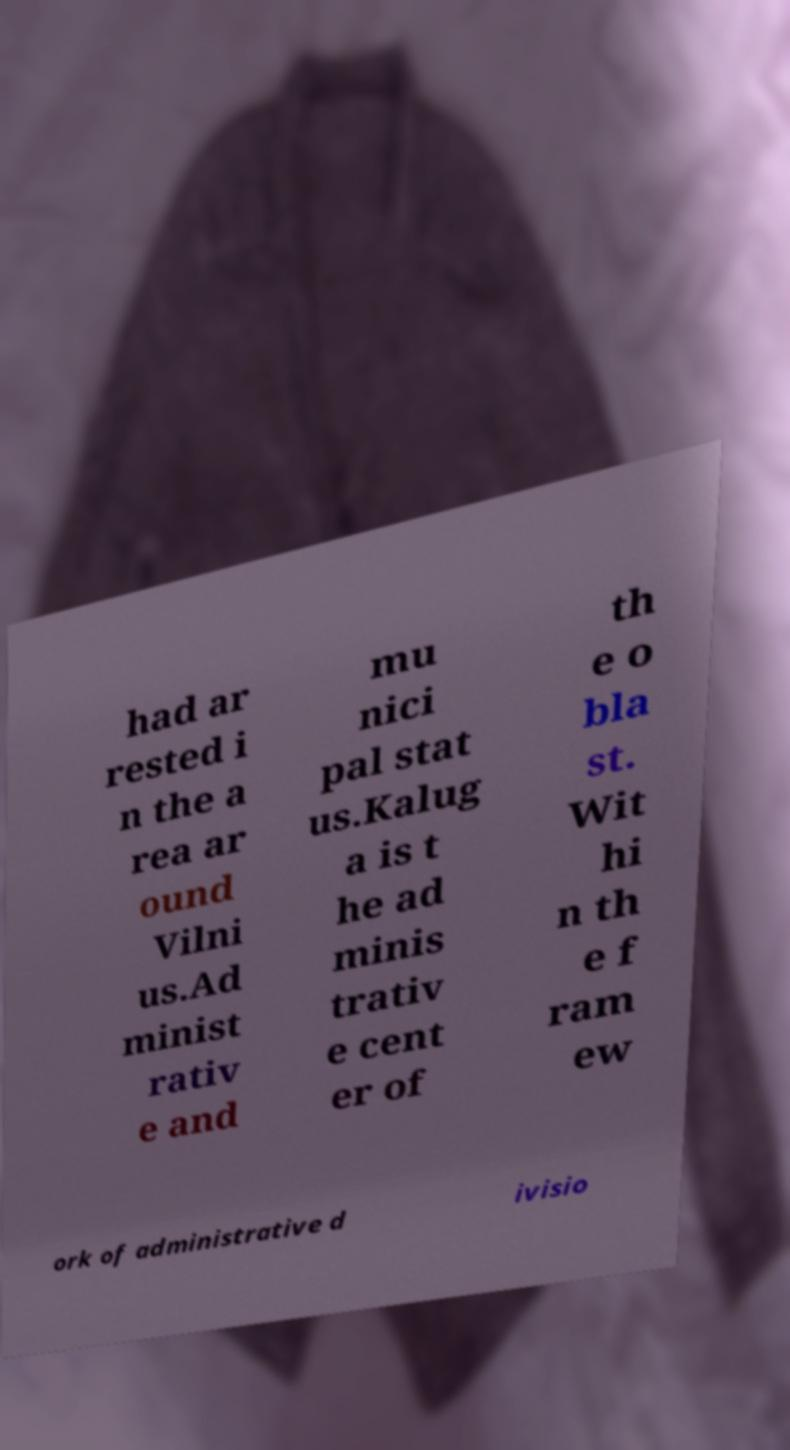What messages or text are displayed in this image? I need them in a readable, typed format. had ar rested i n the a rea ar ound Vilni us.Ad minist rativ e and mu nici pal stat us.Kalug a is t he ad minis trativ e cent er of th e o bla st. Wit hi n th e f ram ew ork of administrative d ivisio 